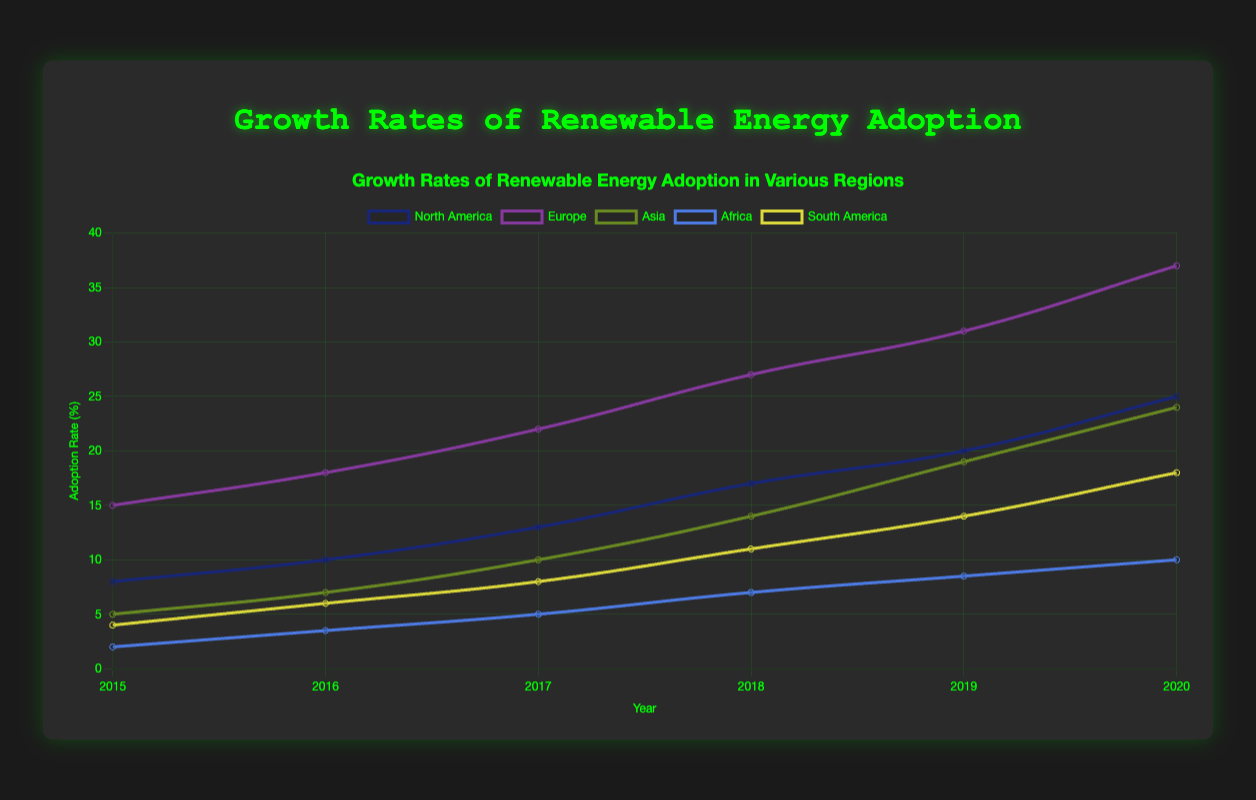Which region had the highest adoption rate in 2020? By observing the highest point on the graph for the year 2020, we can see that Europe has the highest adoption rate at 37%.
Answer: Europe What is the difference in adoption rate between Europe and North America in 2019? In 2019, Europe had an adoption rate of 31% and North America had an adoption rate of 20%. The difference is 31% - 20%, which equals 11%.
Answer: 11% Which region saw the largest growth in adoption rate between 2015 and 2020? We need to compare the increase in adoption rates from 2015 to 2020 for each region. North America grew from 8% to 25% (17%), Europe from 15% to 37% (22%), Asia from 5% to 24% (19%), Africa from 2% to 10% (8%), and South America from 4% to 18% (14%). Europe saw the largest growth of 22%.
Answer: Europe What is the average adoption rate of Asia over the given years? The adoption rates for Asia from 2015 to 2020 are 5%, 7%, 10%, 14%, 19%, and 24%. Summing these gives 5 + 7 + 10 + 14 + 19 + 24 = 79. Dividing by the number of years (6) gives an average of 79/6 ≈ 13.17.
Answer: 13.17 Which region had the slowest growth in adoption rate from 2015 to 2020? From 2015 to 2020, the growth rates were as follows: North America (17%), Europe (22%), Asia (19%), Africa (8%), and South America (14%). Africa had the slowest growth with an 8% increase.
Answer: Africa In what year did South America surpass Africa in adoption rate? South America had an adoption rate of 4% in 2015, which increased each year. Africa had an adoption rate of 2% in 2015. Observing the plotted lines, South America surpassed Africa in 2017, when South America’s adoption rate was 8% and Africa’s was 5%.
Answer: 2017 By how much did the adoption rate in North America increase from 2017 to 2020? North America's adoption rate in 2017 was 13% and in 2020 was 25%. The increase is 25% - 13%, which equals 12%.
Answer: 12% Which two regions had the closest adoption rates in 2018? In 2018, North America had 17%, Europe had 27%, Asia had 14%, Africa had 7%, and South America had 11%. The regions with the closest adoption rates are North America and Asia, with a difference of 17% - 14% = 3%.
Answer: North America and Asia 